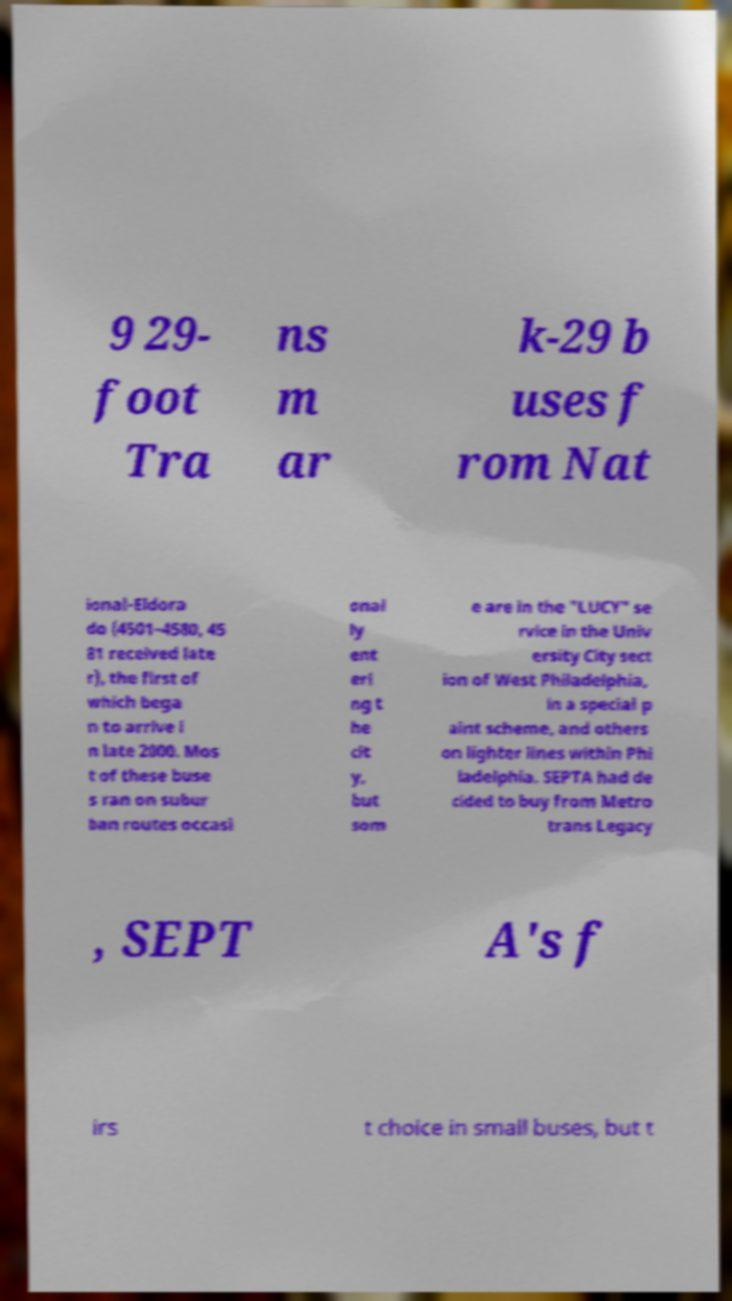Could you extract and type out the text from this image? 9 29- foot Tra ns m ar k-29 b uses f rom Nat ional-Eldora do (4501–4580, 45 81 received late r), the first of which bega n to arrive i n late 2000. Mos t of these buse s ran on subur ban routes occasi onal ly ent eri ng t he cit y, but som e are in the "LUCY" se rvice in the Univ ersity City sect ion of West Philadelphia, in a special p aint scheme, and others on lighter lines within Phi ladelphia. SEPTA had de cided to buy from Metro trans Legacy , SEPT A's f irs t choice in small buses, but t 